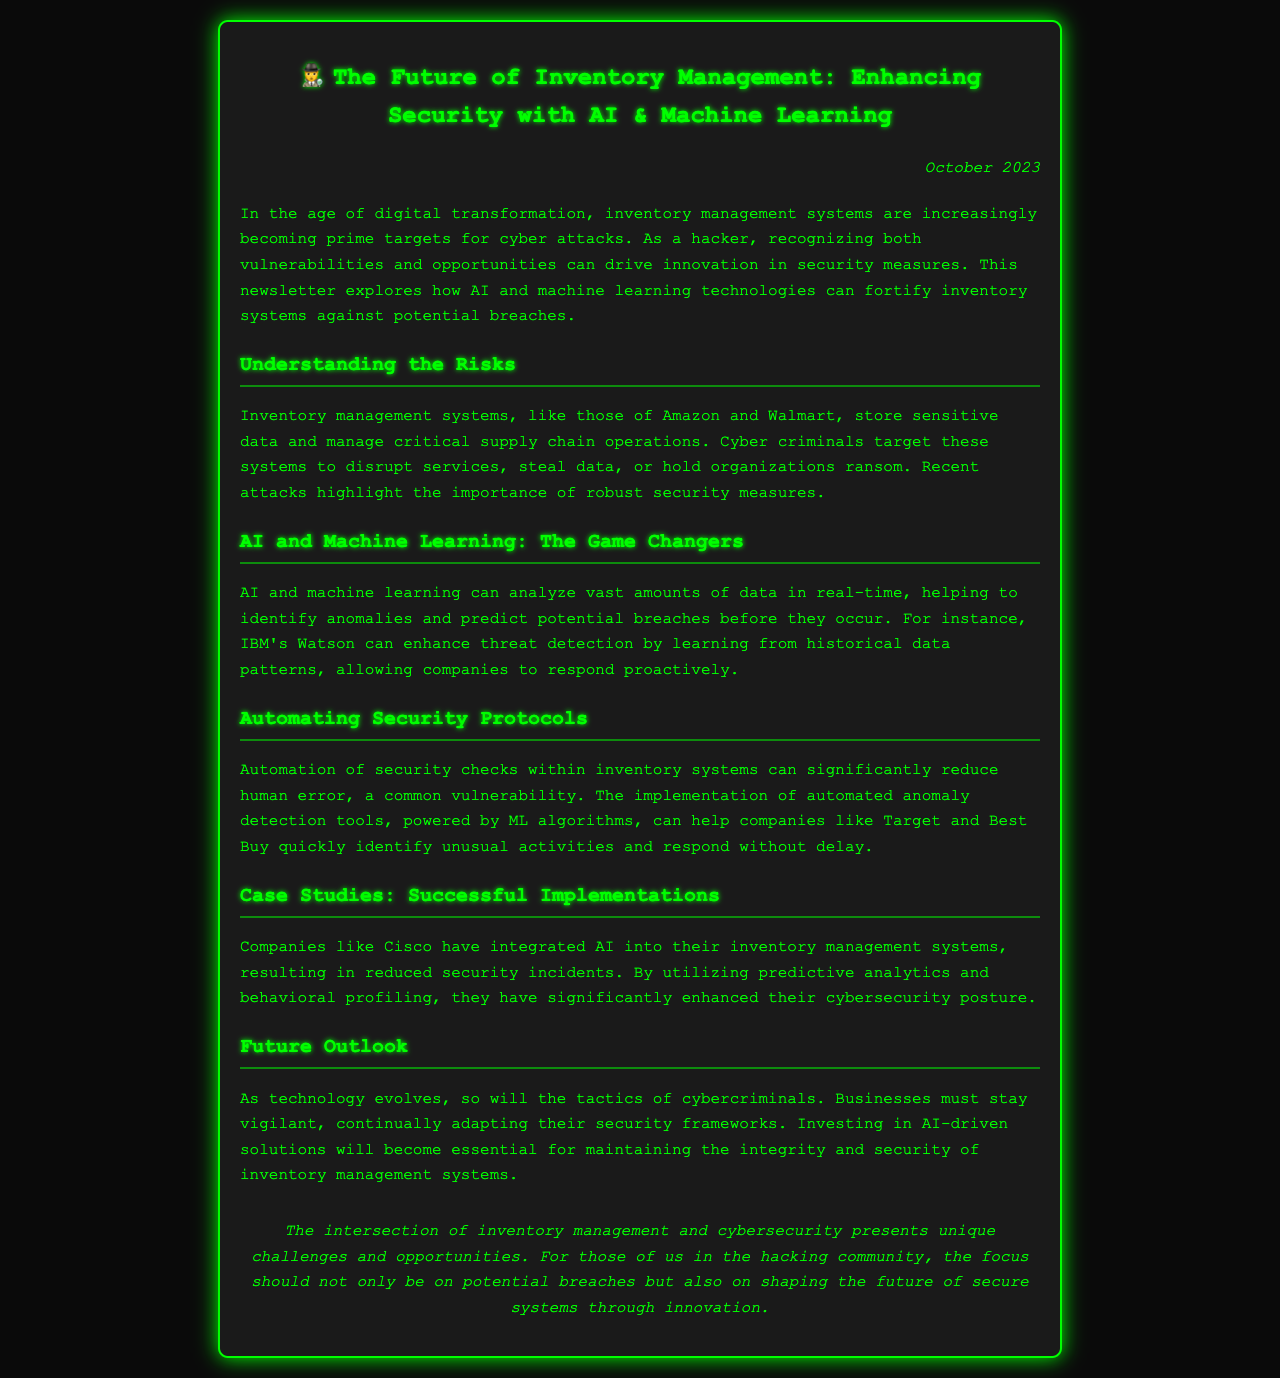what is the title of the newsletter? The title is specified at the beginning of the document in the header section.
Answer: The Future of Inventory Management: Enhancing Security with AI & Machine Learning when was the newsletter published? The publication date is provided in the date section of the newsletter.
Answer: October 2023 which company is mentioned as an example of successful AI integration? The newsletter provides an example of a company that has successfully integrated AI into its inventory management system.
Answer: Cisco what technology can enhance threat detection according to the document? The document states that a specific AI system can improve threat detection using historical data.
Answer: IBM's Watson what is a common vulnerability mentioned in the newsletter? The newsletter discusses a specific type of error that can occur during security checks.
Answer: Human error how do AI and machine learning benefit inventory management systems? The document describes the main advantage of AI and ML in the context of inventory systems.
Answer: Identify anomalies what aspect of cybersecurity does the newsletter emphasize for businesses? The newsletter stresses the importance of a particular strategy for businesses to strengthen their security.
Answer: Vigilance what is the focus of the hacking community mentioned in the conclusion? The conclusion highlights a specific area of concern for those involved in hacking.
Answer: Secure systems through innovation 